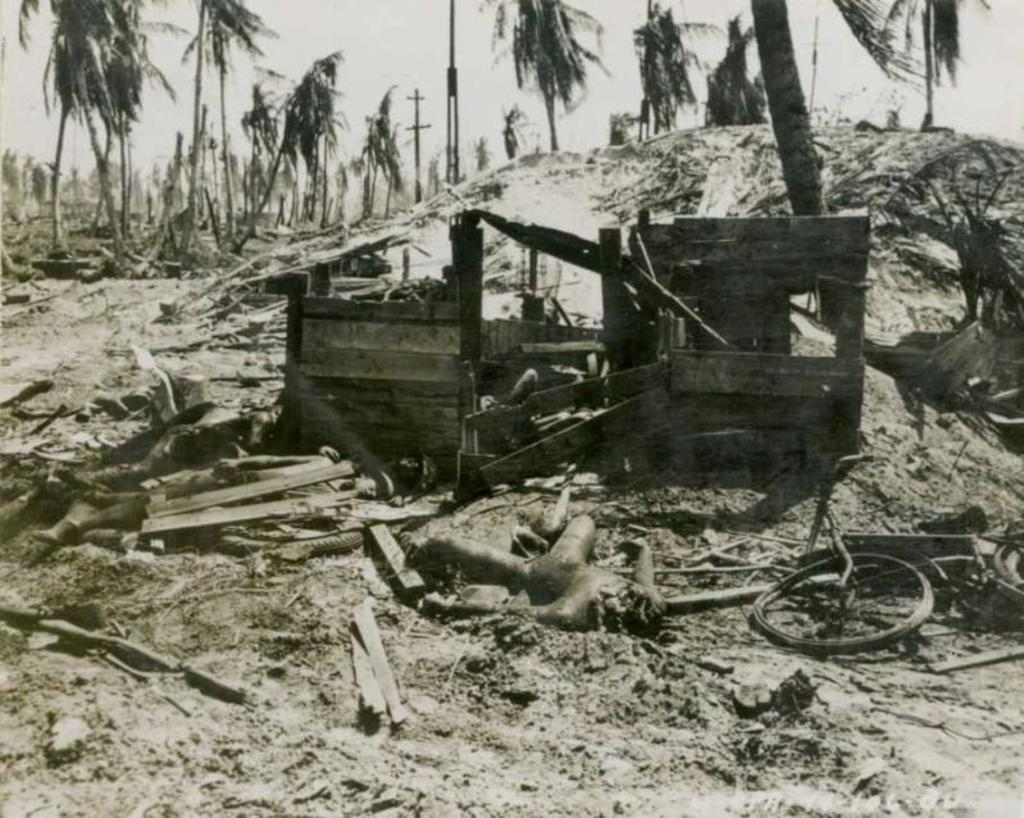What is the color scheme of the image? The image is black and white. What can be seen at the top of the image? There are trees at the top of the image. What is located in the middle of the image? There is waste material in the middle of the image. What is visible at the top of the image besides the trees? The sky is visible at the top of the image. Can you tell me how many records are spinning in a circle in the image? There are no records or circles present in the image; it features trees, waste material, and a black and white color scheme. What type of quarter is depicted in the image? There is no quarter present in the image. 